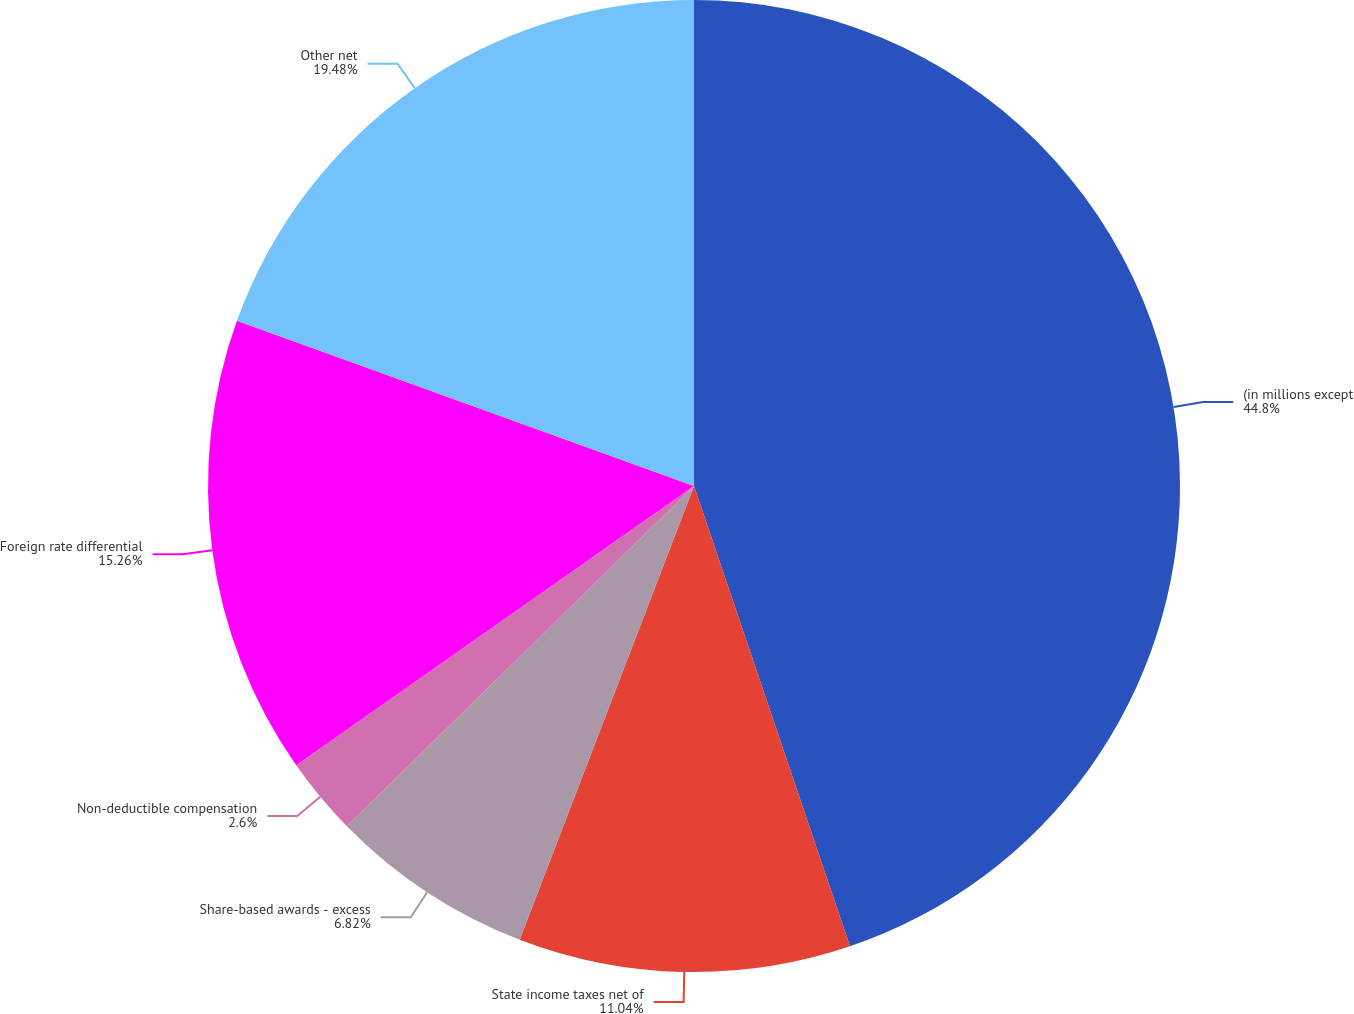<chart> <loc_0><loc_0><loc_500><loc_500><pie_chart><fcel>(in millions except<fcel>State income taxes net of<fcel>Share-based awards - excess<fcel>Non-deductible compensation<fcel>Foreign rate differential<fcel>Other net<nl><fcel>44.8%<fcel>11.04%<fcel>6.82%<fcel>2.6%<fcel>15.26%<fcel>19.48%<nl></chart> 